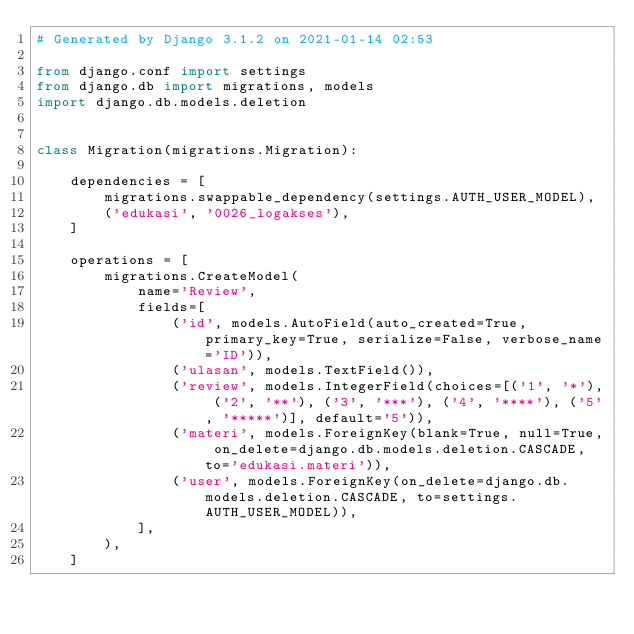Convert code to text. <code><loc_0><loc_0><loc_500><loc_500><_Python_># Generated by Django 3.1.2 on 2021-01-14 02:53

from django.conf import settings
from django.db import migrations, models
import django.db.models.deletion


class Migration(migrations.Migration):

    dependencies = [
        migrations.swappable_dependency(settings.AUTH_USER_MODEL),
        ('edukasi', '0026_logakses'),
    ]

    operations = [
        migrations.CreateModel(
            name='Review',
            fields=[
                ('id', models.AutoField(auto_created=True, primary_key=True, serialize=False, verbose_name='ID')),
                ('ulasan', models.TextField()),
                ('review', models.IntegerField(choices=[('1', '*'), ('2', '**'), ('3', '***'), ('4', '****'), ('5', '*****')], default='5')),
                ('materi', models.ForeignKey(blank=True, null=True, on_delete=django.db.models.deletion.CASCADE, to='edukasi.materi')),
                ('user', models.ForeignKey(on_delete=django.db.models.deletion.CASCADE, to=settings.AUTH_USER_MODEL)),
            ],
        ),
    ]
</code> 